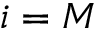Convert formula to latex. <formula><loc_0><loc_0><loc_500><loc_500>i = M</formula> 